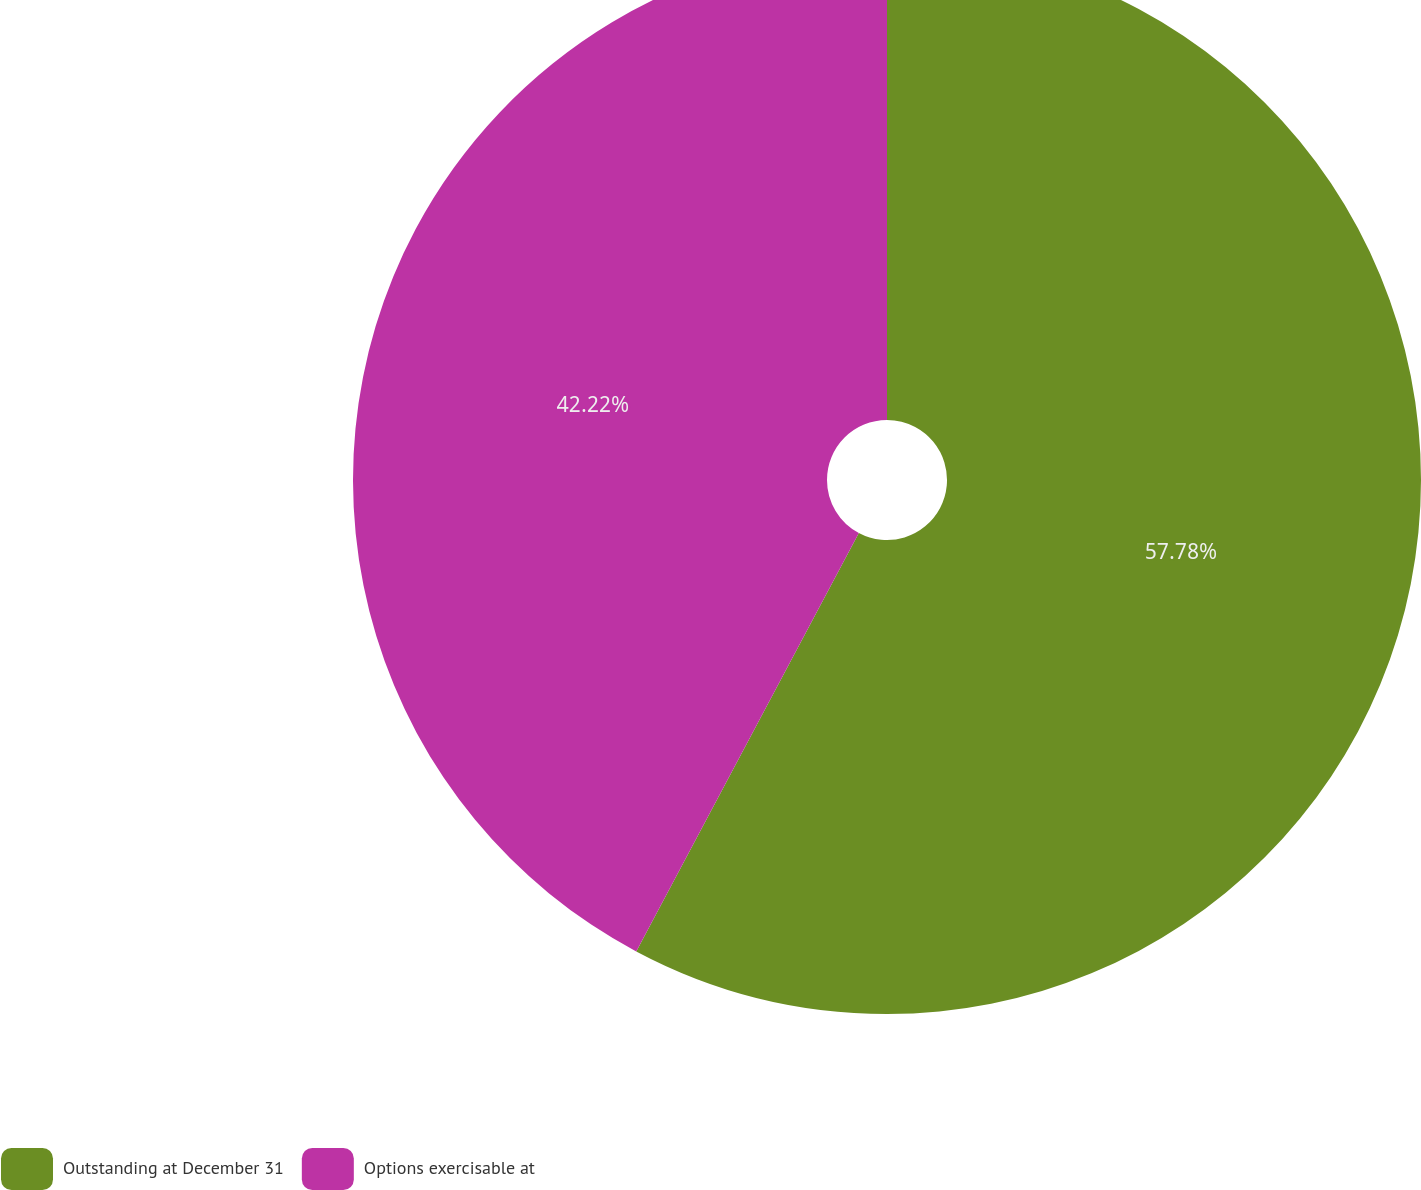<chart> <loc_0><loc_0><loc_500><loc_500><pie_chart><fcel>Outstanding at December 31<fcel>Options exercisable at<nl><fcel>57.78%<fcel>42.22%<nl></chart> 